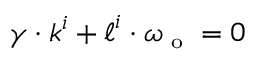<formula> <loc_0><loc_0><loc_500><loc_500>\gamma \cdot k ^ { i } + \ell ^ { i } \cdot \omega _ { o } = 0</formula> 